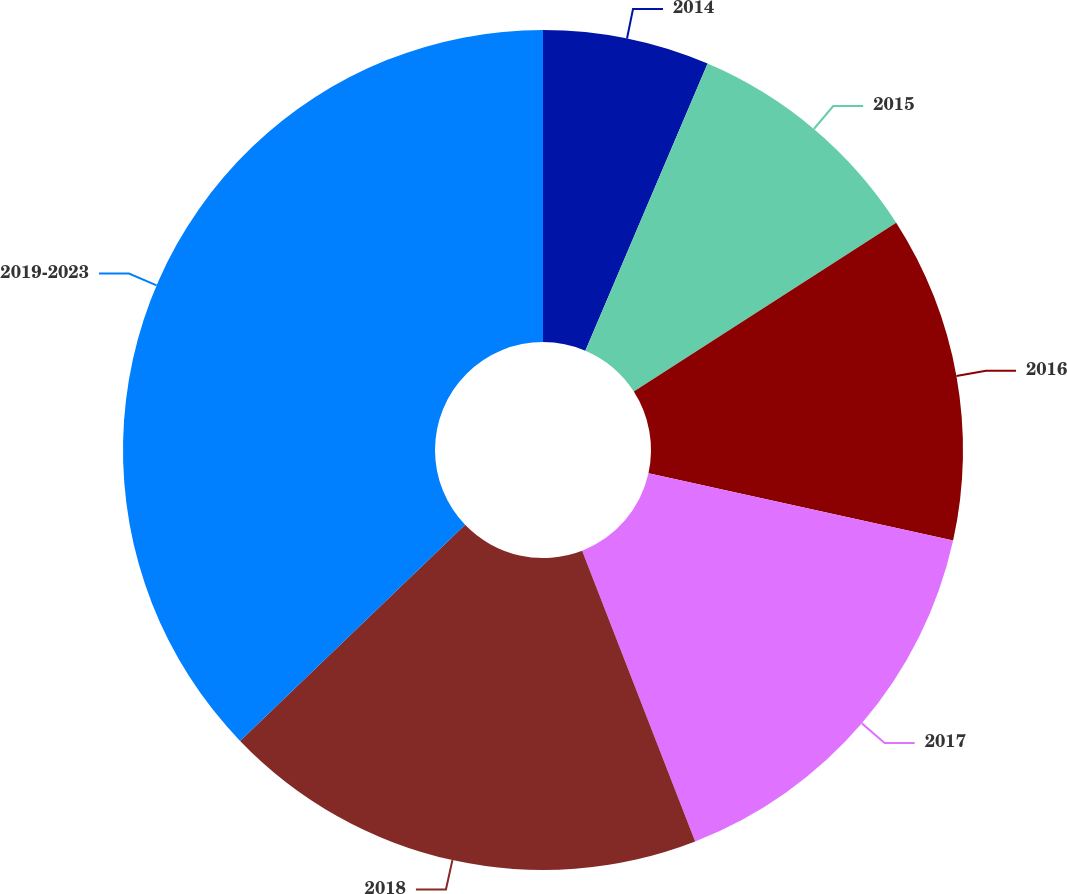Convert chart. <chart><loc_0><loc_0><loc_500><loc_500><pie_chart><fcel>2014<fcel>2015<fcel>2016<fcel>2017<fcel>2018<fcel>2019-2023<nl><fcel>6.41%<fcel>9.49%<fcel>12.56%<fcel>15.64%<fcel>18.72%<fcel>37.18%<nl></chart> 